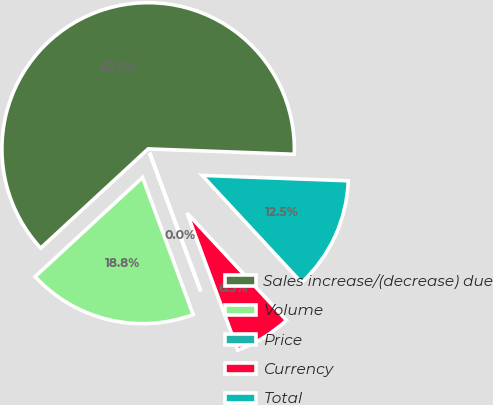Convert chart to OTSL. <chart><loc_0><loc_0><loc_500><loc_500><pie_chart><fcel>Sales increase/(decrease) due<fcel>Volume<fcel>Price<fcel>Currency<fcel>Total<nl><fcel>62.45%<fcel>18.75%<fcel>0.02%<fcel>6.26%<fcel>12.51%<nl></chart> 